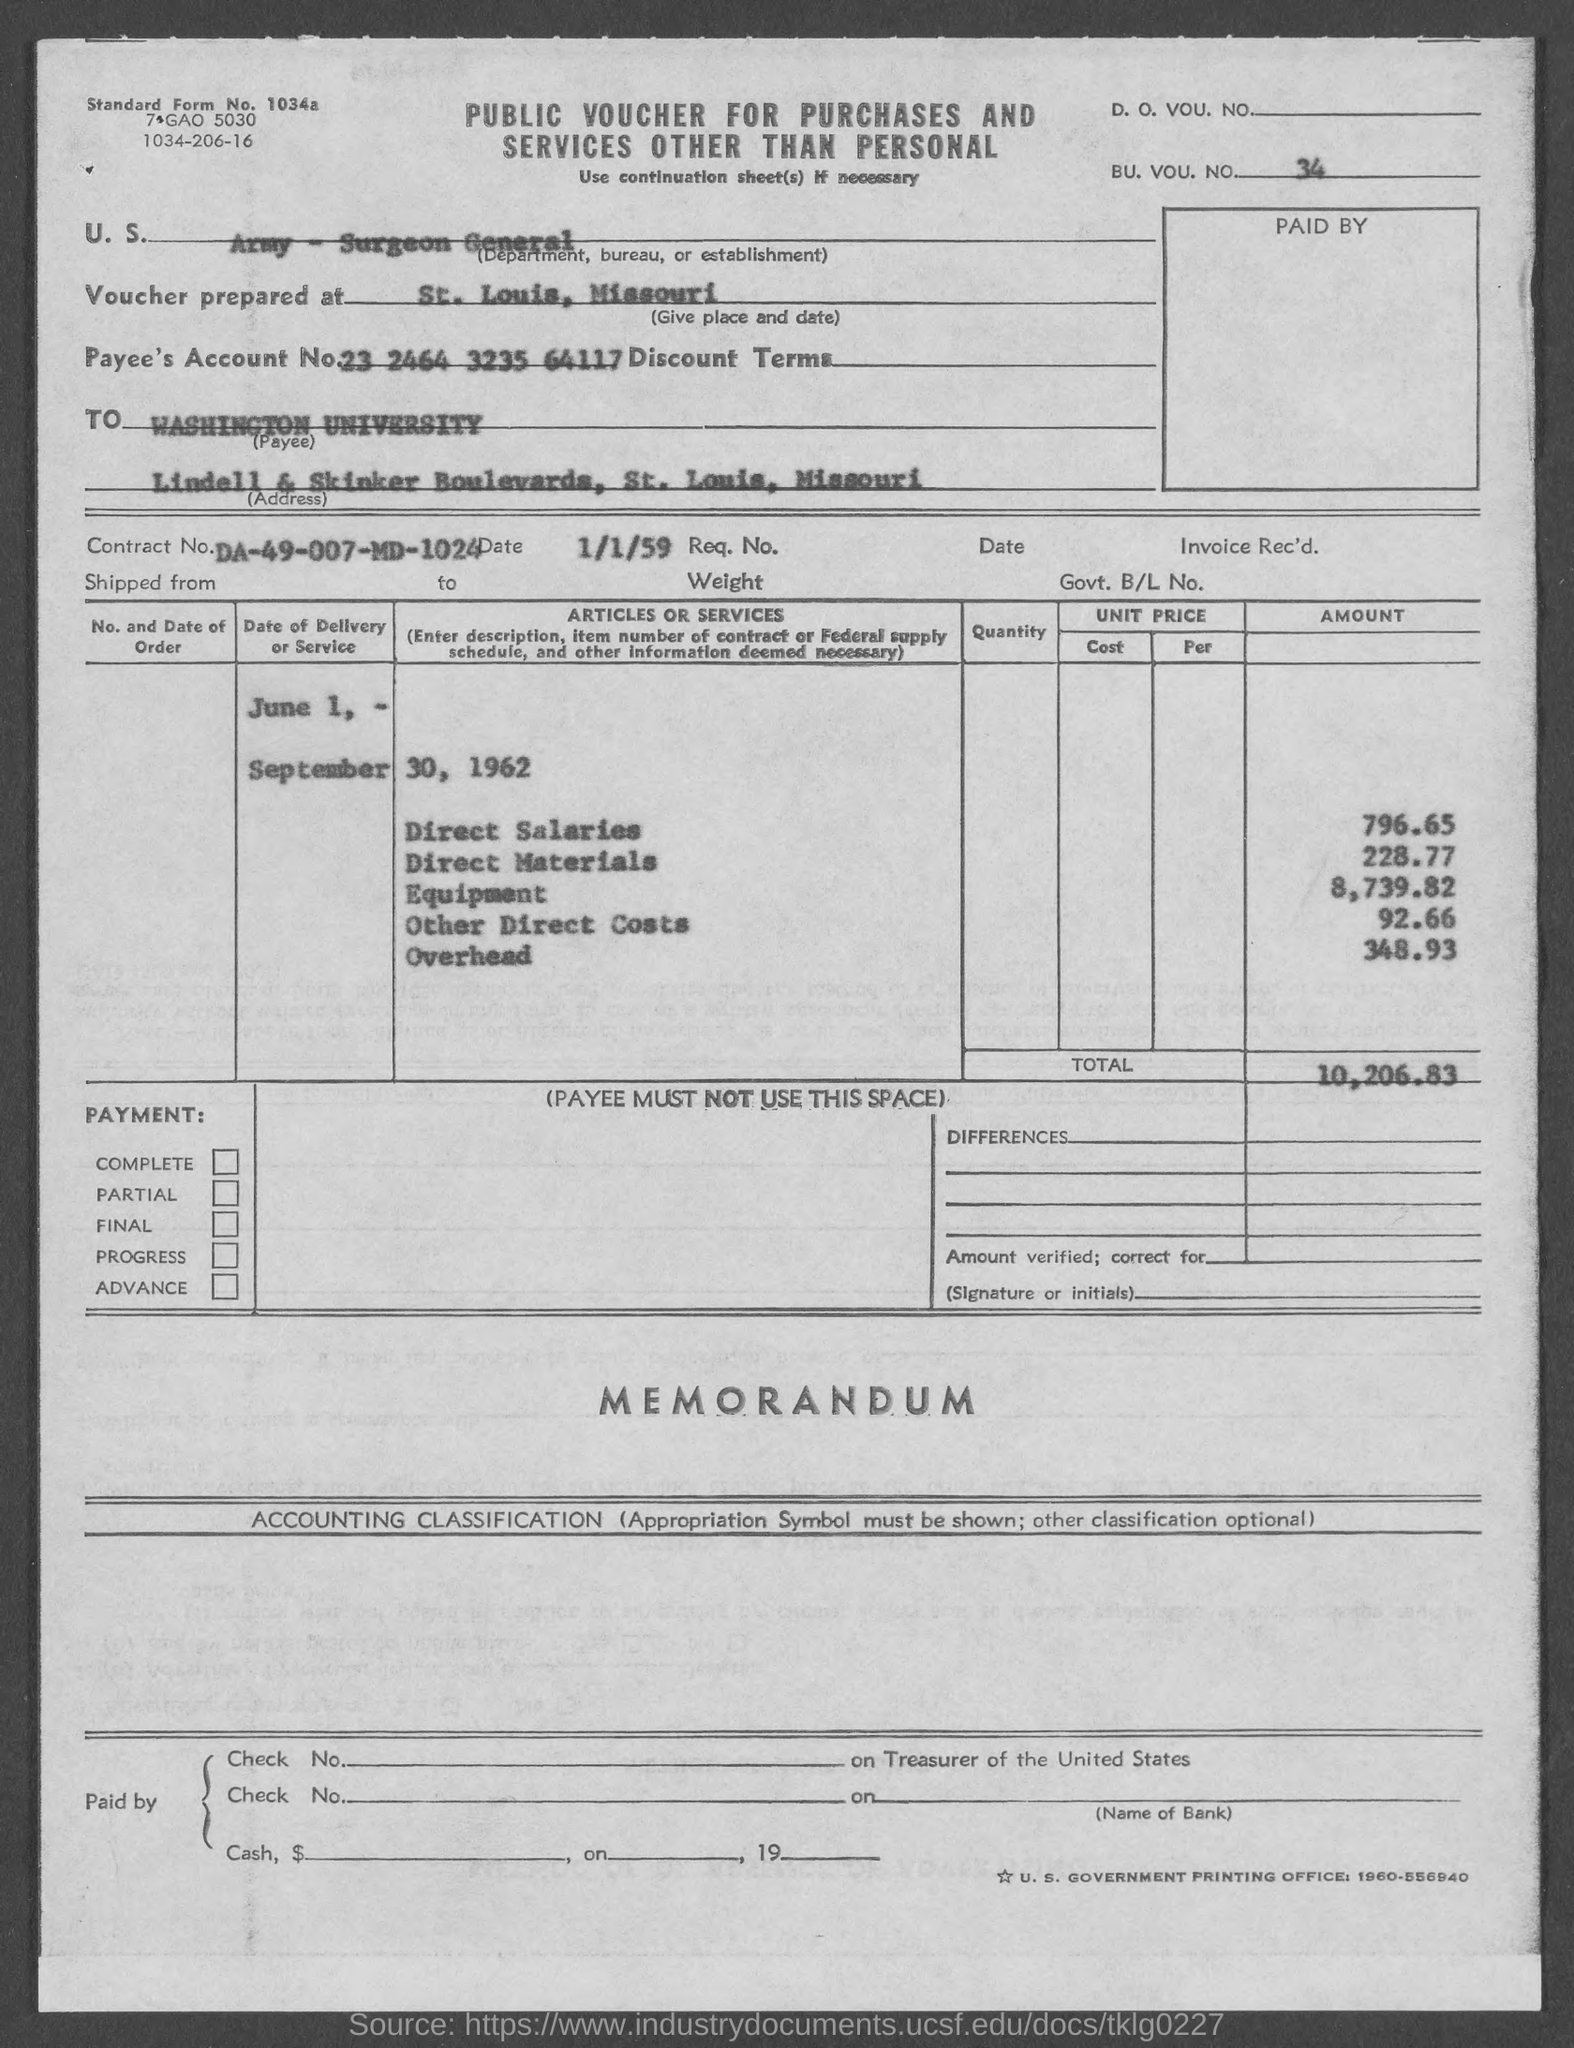What is the standard form no.?
Keep it short and to the point. 1034a. What bu. vou. no.?
Offer a very short reply. 34. What is the payee's account no.?
Offer a very short reply. 23 2464 3235 64117. What is the contract no.?
Offer a terse response. DA-49-007-MD-1024. In which county is washington university  located?
Provide a succinct answer. St. Louis. What is the total amount ?
Offer a very short reply. $10,206.83. What is the direct salaries amount ?
Your response must be concise. $796.65. What is the direct materials amount ?
Give a very brief answer. 228.77. What is the equipment amount ?
Give a very brief answer. 8,739.82. What is the other direct costs ?
Give a very brief answer. 92.66. 